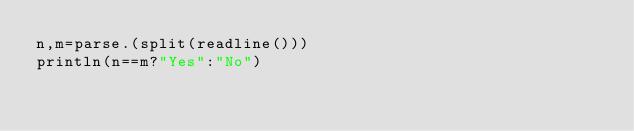<code> <loc_0><loc_0><loc_500><loc_500><_Julia_>n,m=parse.(split(readline()))
println(n==m?"Yes":"No")</code> 